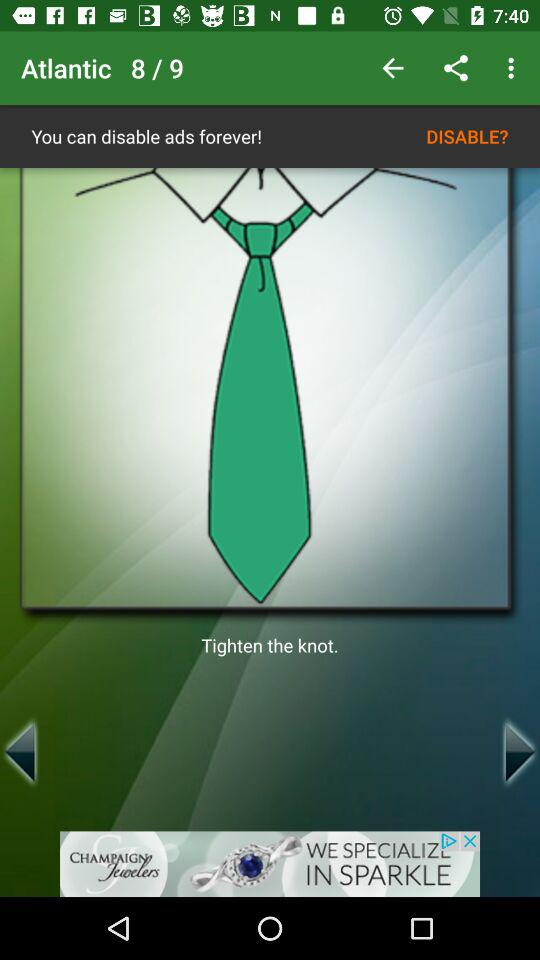How many images in total are there? There are 9 images in total. 